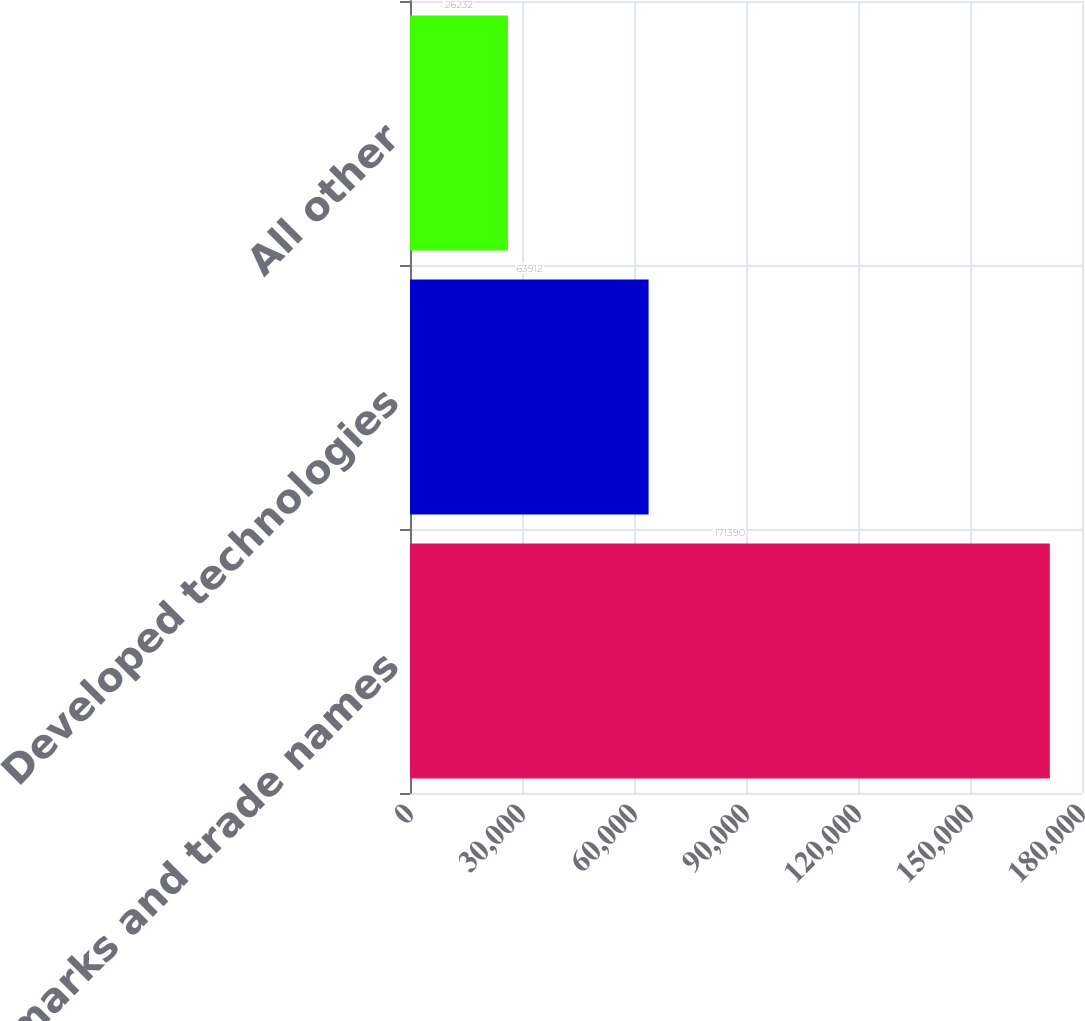Convert chart. <chart><loc_0><loc_0><loc_500><loc_500><bar_chart><fcel>Trademarks and trade names<fcel>Developed technologies<fcel>All other<nl><fcel>171390<fcel>63912<fcel>26232<nl></chart> 